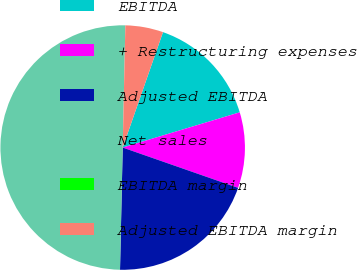Convert chart. <chart><loc_0><loc_0><loc_500><loc_500><pie_chart><fcel>EBITDA<fcel>+ Restructuring expenses<fcel>Adjusted EBITDA<fcel>Net sales<fcel>EBITDA margin<fcel>Adjusted EBITDA margin<nl><fcel>15.0%<fcel>10.0%<fcel>20.0%<fcel>50.0%<fcel>0.0%<fcel>5.0%<nl></chart> 